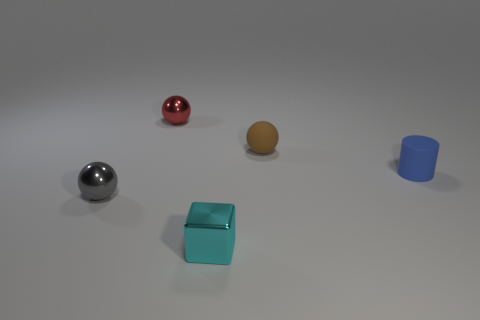What is the shape of the tiny object in front of the small ball that is in front of the small sphere that is right of the cyan metallic object?
Your answer should be compact. Cube. How big is the metallic block?
Provide a succinct answer. Small. There is a ball that is made of the same material as the small red object; what is its color?
Give a very brief answer. Gray. How many blue cubes have the same material as the tiny cylinder?
Offer a terse response. 0. There is a tiny rubber cylinder; is it the same color as the small metal thing in front of the gray metal object?
Your answer should be compact. No. There is a ball that is to the right of the small object in front of the small gray metal sphere; what is its color?
Ensure brevity in your answer.  Brown. What color is the other shiny sphere that is the same size as the red sphere?
Make the answer very short. Gray. Are there any small gray metallic things that have the same shape as the tiny blue object?
Give a very brief answer. No. The tiny red thing has what shape?
Provide a short and direct response. Sphere. Is the number of tiny cylinders that are to the left of the small red sphere greater than the number of blue matte objects on the left side of the blue rubber thing?
Offer a very short reply. No. 